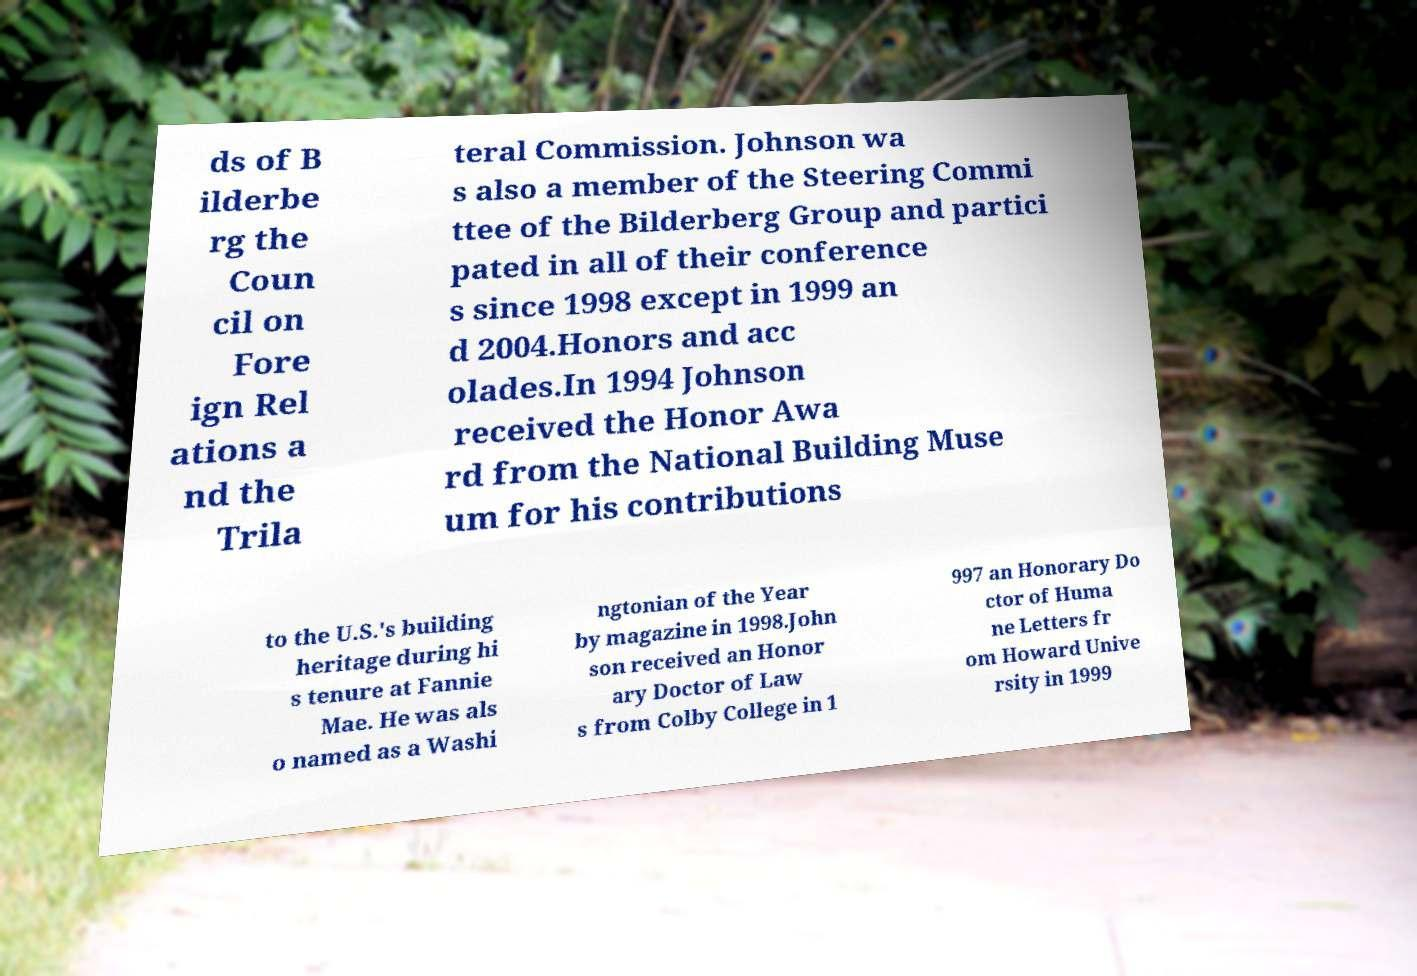Please read and relay the text visible in this image. What does it say? ds of B ilderbe rg the Coun cil on Fore ign Rel ations a nd the Trila teral Commission. Johnson wa s also a member of the Steering Commi ttee of the Bilderberg Group and partici pated in all of their conference s since 1998 except in 1999 an d 2004.Honors and acc olades.In 1994 Johnson received the Honor Awa rd from the National Building Muse um for his contributions to the U.S.'s building heritage during hi s tenure at Fannie Mae. He was als o named as a Washi ngtonian of the Year by magazine in 1998.John son received an Honor ary Doctor of Law s from Colby College in 1 997 an Honorary Do ctor of Huma ne Letters fr om Howard Unive rsity in 1999 